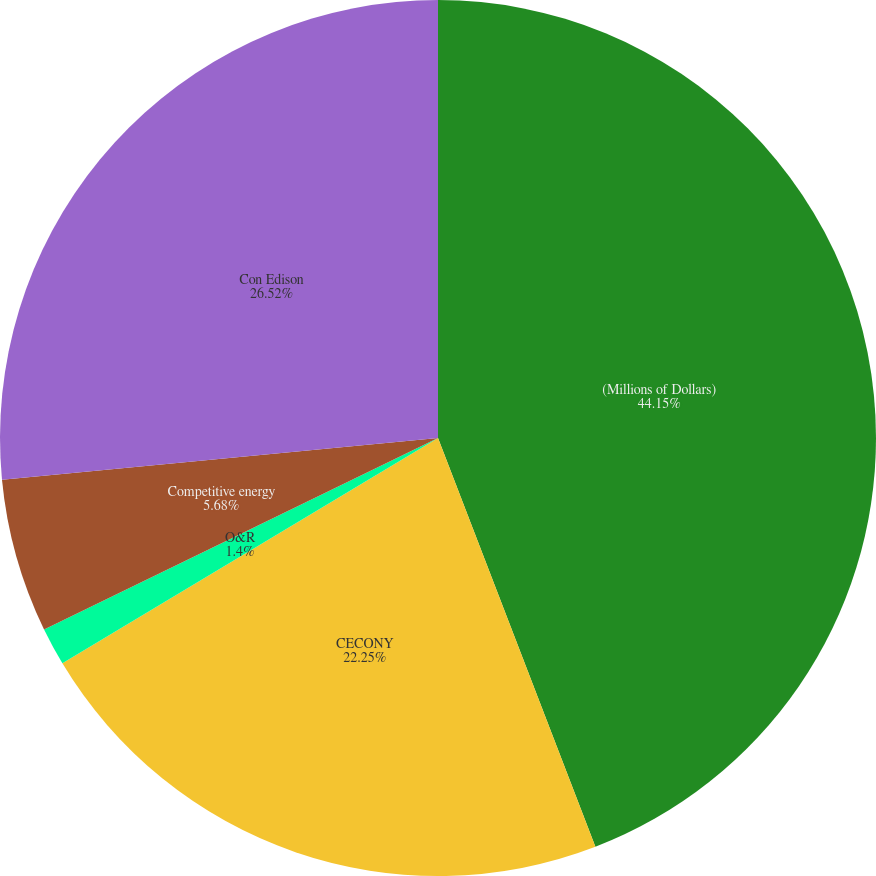Convert chart. <chart><loc_0><loc_0><loc_500><loc_500><pie_chart><fcel>(Millions of Dollars)<fcel>CECONY<fcel>O&R<fcel>Competitive energy<fcel>Con Edison<nl><fcel>44.15%<fcel>22.25%<fcel>1.4%<fcel>5.68%<fcel>26.52%<nl></chart> 